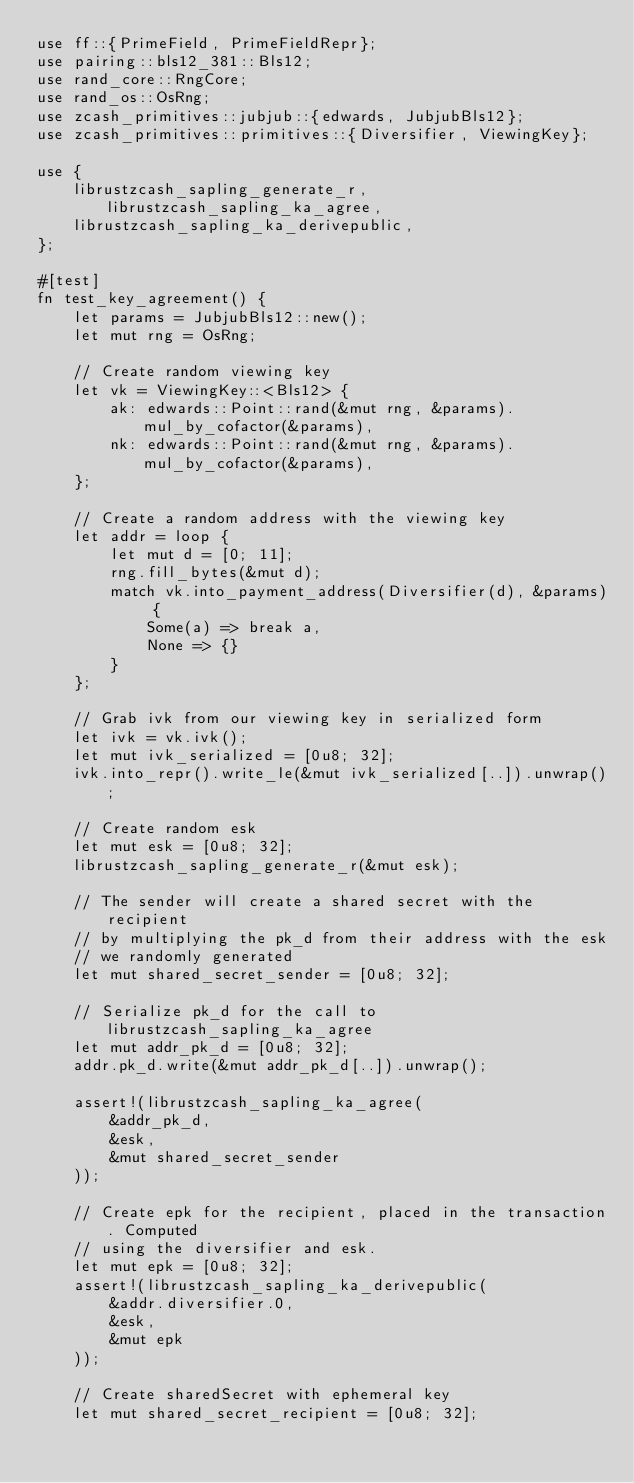Convert code to text. <code><loc_0><loc_0><loc_500><loc_500><_Rust_>use ff::{PrimeField, PrimeFieldRepr};
use pairing::bls12_381::Bls12;
use rand_core::RngCore;
use rand_os::OsRng;
use zcash_primitives::jubjub::{edwards, JubjubBls12};
use zcash_primitives::primitives::{Diversifier, ViewingKey};

use {
    librustzcash_sapling_generate_r, librustzcash_sapling_ka_agree,
    librustzcash_sapling_ka_derivepublic,
};

#[test]
fn test_key_agreement() {
    let params = JubjubBls12::new();
    let mut rng = OsRng;

    // Create random viewing key
    let vk = ViewingKey::<Bls12> {
        ak: edwards::Point::rand(&mut rng, &params).mul_by_cofactor(&params),
        nk: edwards::Point::rand(&mut rng, &params).mul_by_cofactor(&params),
    };

    // Create a random address with the viewing key
    let addr = loop {
        let mut d = [0; 11];
        rng.fill_bytes(&mut d);
        match vk.into_payment_address(Diversifier(d), &params) {
            Some(a) => break a,
            None => {}
        }
    };

    // Grab ivk from our viewing key in serialized form
    let ivk = vk.ivk();
    let mut ivk_serialized = [0u8; 32];
    ivk.into_repr().write_le(&mut ivk_serialized[..]).unwrap();

    // Create random esk
    let mut esk = [0u8; 32];
    librustzcash_sapling_generate_r(&mut esk);

    // The sender will create a shared secret with the recipient
    // by multiplying the pk_d from their address with the esk
    // we randomly generated
    let mut shared_secret_sender = [0u8; 32];

    // Serialize pk_d for the call to librustzcash_sapling_ka_agree
    let mut addr_pk_d = [0u8; 32];
    addr.pk_d.write(&mut addr_pk_d[..]).unwrap();

    assert!(librustzcash_sapling_ka_agree(
        &addr_pk_d,
        &esk,
        &mut shared_secret_sender
    ));

    // Create epk for the recipient, placed in the transaction. Computed
    // using the diversifier and esk.
    let mut epk = [0u8; 32];
    assert!(librustzcash_sapling_ka_derivepublic(
        &addr.diversifier.0,
        &esk,
        &mut epk
    ));

    // Create sharedSecret with ephemeral key
    let mut shared_secret_recipient = [0u8; 32];</code> 